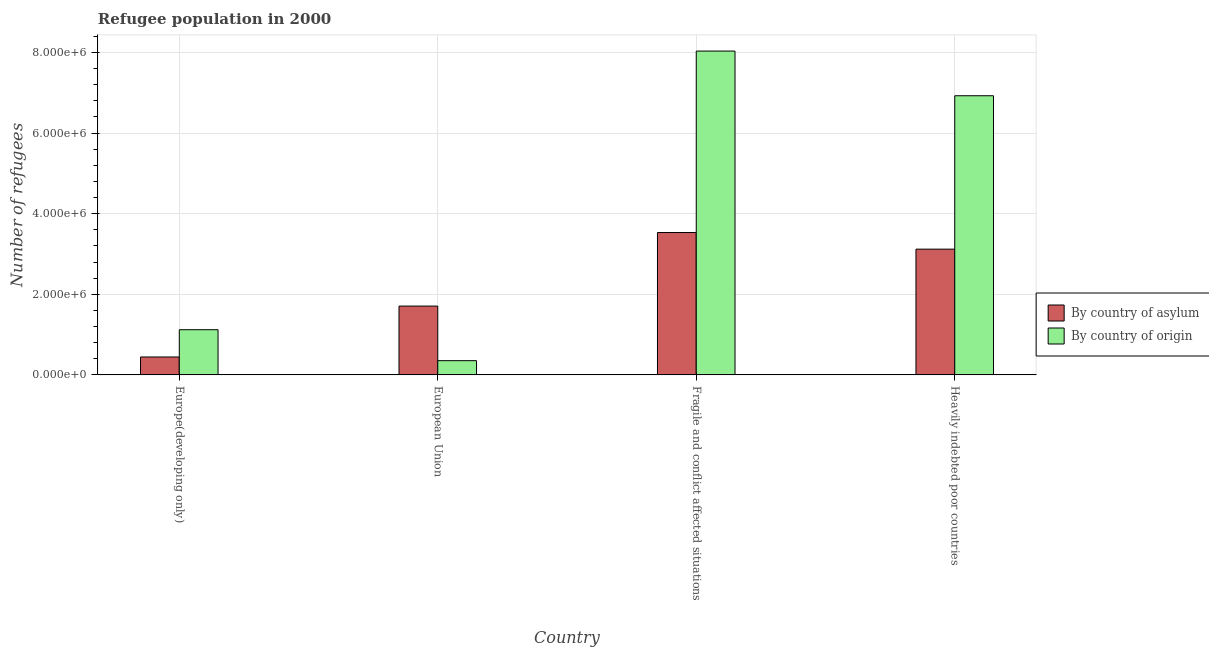Are the number of bars on each tick of the X-axis equal?
Keep it short and to the point. Yes. How many bars are there on the 1st tick from the left?
Your answer should be very brief. 2. What is the label of the 3rd group of bars from the left?
Ensure brevity in your answer.  Fragile and conflict affected situations. In how many cases, is the number of bars for a given country not equal to the number of legend labels?
Your response must be concise. 0. What is the number of refugees by country of asylum in Heavily indebted poor countries?
Your response must be concise. 3.12e+06. Across all countries, what is the maximum number of refugees by country of asylum?
Keep it short and to the point. 3.53e+06. Across all countries, what is the minimum number of refugees by country of origin?
Keep it short and to the point. 3.54e+05. In which country was the number of refugees by country of asylum maximum?
Offer a terse response. Fragile and conflict affected situations. In which country was the number of refugees by country of asylum minimum?
Offer a very short reply. Europe(developing only). What is the total number of refugees by country of origin in the graph?
Provide a short and direct response. 1.64e+07. What is the difference between the number of refugees by country of asylum in Europe(developing only) and that in Fragile and conflict affected situations?
Provide a short and direct response. -3.09e+06. What is the difference between the number of refugees by country of origin in Heavily indebted poor countries and the number of refugees by country of asylum in Europe(developing only)?
Your answer should be compact. 6.48e+06. What is the average number of refugees by country of origin per country?
Offer a very short reply. 4.11e+06. What is the difference between the number of refugees by country of origin and number of refugees by country of asylum in Fragile and conflict affected situations?
Provide a succinct answer. 4.50e+06. What is the ratio of the number of refugees by country of origin in Fragile and conflict affected situations to that in Heavily indebted poor countries?
Give a very brief answer. 1.16. Is the number of refugees by country of asylum in European Union less than that in Fragile and conflict affected situations?
Your answer should be very brief. Yes. What is the difference between the highest and the second highest number of refugees by country of origin?
Ensure brevity in your answer.  1.11e+06. What is the difference between the highest and the lowest number of refugees by country of asylum?
Your answer should be very brief. 3.09e+06. Is the sum of the number of refugees by country of origin in Europe(developing only) and European Union greater than the maximum number of refugees by country of asylum across all countries?
Your response must be concise. No. What does the 1st bar from the left in Fragile and conflict affected situations represents?
Provide a succinct answer. By country of asylum. What does the 1st bar from the right in Europe(developing only) represents?
Give a very brief answer. By country of origin. How many bars are there?
Offer a terse response. 8. Are all the bars in the graph horizontal?
Offer a very short reply. No. What is the difference between two consecutive major ticks on the Y-axis?
Provide a succinct answer. 2.00e+06. Does the graph contain grids?
Offer a terse response. Yes. Where does the legend appear in the graph?
Offer a terse response. Center right. How many legend labels are there?
Provide a short and direct response. 2. How are the legend labels stacked?
Provide a succinct answer. Vertical. What is the title of the graph?
Make the answer very short. Refugee population in 2000. What is the label or title of the X-axis?
Your answer should be very brief. Country. What is the label or title of the Y-axis?
Make the answer very short. Number of refugees. What is the Number of refugees of By country of asylum in Europe(developing only)?
Offer a terse response. 4.45e+05. What is the Number of refugees of By country of origin in Europe(developing only)?
Make the answer very short. 1.12e+06. What is the Number of refugees in By country of asylum in European Union?
Your answer should be compact. 1.71e+06. What is the Number of refugees of By country of origin in European Union?
Your answer should be very brief. 3.54e+05. What is the Number of refugees of By country of asylum in Fragile and conflict affected situations?
Your response must be concise. 3.53e+06. What is the Number of refugees in By country of origin in Fragile and conflict affected situations?
Provide a short and direct response. 8.03e+06. What is the Number of refugees in By country of asylum in Heavily indebted poor countries?
Keep it short and to the point. 3.12e+06. What is the Number of refugees in By country of origin in Heavily indebted poor countries?
Give a very brief answer. 6.93e+06. Across all countries, what is the maximum Number of refugees of By country of asylum?
Ensure brevity in your answer.  3.53e+06. Across all countries, what is the maximum Number of refugees of By country of origin?
Provide a short and direct response. 8.03e+06. Across all countries, what is the minimum Number of refugees in By country of asylum?
Your answer should be very brief. 4.45e+05. Across all countries, what is the minimum Number of refugees of By country of origin?
Ensure brevity in your answer.  3.54e+05. What is the total Number of refugees in By country of asylum in the graph?
Offer a very short reply. 8.80e+06. What is the total Number of refugees of By country of origin in the graph?
Your response must be concise. 1.64e+07. What is the difference between the Number of refugees of By country of asylum in Europe(developing only) and that in European Union?
Offer a very short reply. -1.26e+06. What is the difference between the Number of refugees of By country of origin in Europe(developing only) and that in European Union?
Your answer should be very brief. 7.68e+05. What is the difference between the Number of refugees in By country of asylum in Europe(developing only) and that in Fragile and conflict affected situations?
Offer a terse response. -3.09e+06. What is the difference between the Number of refugees in By country of origin in Europe(developing only) and that in Fragile and conflict affected situations?
Your answer should be compact. -6.91e+06. What is the difference between the Number of refugees in By country of asylum in Europe(developing only) and that in Heavily indebted poor countries?
Offer a very short reply. -2.67e+06. What is the difference between the Number of refugees in By country of origin in Europe(developing only) and that in Heavily indebted poor countries?
Your response must be concise. -5.80e+06. What is the difference between the Number of refugees of By country of asylum in European Union and that in Fragile and conflict affected situations?
Offer a terse response. -1.82e+06. What is the difference between the Number of refugees in By country of origin in European Union and that in Fragile and conflict affected situations?
Your answer should be very brief. -7.68e+06. What is the difference between the Number of refugees in By country of asylum in European Union and that in Heavily indebted poor countries?
Your answer should be very brief. -1.41e+06. What is the difference between the Number of refugees in By country of origin in European Union and that in Heavily indebted poor countries?
Make the answer very short. -6.57e+06. What is the difference between the Number of refugees in By country of asylum in Fragile and conflict affected situations and that in Heavily indebted poor countries?
Provide a short and direct response. 4.12e+05. What is the difference between the Number of refugees of By country of origin in Fragile and conflict affected situations and that in Heavily indebted poor countries?
Your response must be concise. 1.11e+06. What is the difference between the Number of refugees of By country of asylum in Europe(developing only) and the Number of refugees of By country of origin in European Union?
Keep it short and to the point. 9.15e+04. What is the difference between the Number of refugees in By country of asylum in Europe(developing only) and the Number of refugees in By country of origin in Fragile and conflict affected situations?
Keep it short and to the point. -7.59e+06. What is the difference between the Number of refugees in By country of asylum in Europe(developing only) and the Number of refugees in By country of origin in Heavily indebted poor countries?
Provide a short and direct response. -6.48e+06. What is the difference between the Number of refugees of By country of asylum in European Union and the Number of refugees of By country of origin in Fragile and conflict affected situations?
Ensure brevity in your answer.  -6.33e+06. What is the difference between the Number of refugees of By country of asylum in European Union and the Number of refugees of By country of origin in Heavily indebted poor countries?
Provide a short and direct response. -5.22e+06. What is the difference between the Number of refugees of By country of asylum in Fragile and conflict affected situations and the Number of refugees of By country of origin in Heavily indebted poor countries?
Make the answer very short. -3.39e+06. What is the average Number of refugees of By country of asylum per country?
Your response must be concise. 2.20e+06. What is the average Number of refugees in By country of origin per country?
Make the answer very short. 4.11e+06. What is the difference between the Number of refugees in By country of asylum and Number of refugees in By country of origin in Europe(developing only)?
Your answer should be compact. -6.76e+05. What is the difference between the Number of refugees in By country of asylum and Number of refugees in By country of origin in European Union?
Offer a very short reply. 1.35e+06. What is the difference between the Number of refugees of By country of asylum and Number of refugees of By country of origin in Fragile and conflict affected situations?
Make the answer very short. -4.50e+06. What is the difference between the Number of refugees in By country of asylum and Number of refugees in By country of origin in Heavily indebted poor countries?
Your answer should be very brief. -3.81e+06. What is the ratio of the Number of refugees in By country of asylum in Europe(developing only) to that in European Union?
Offer a terse response. 0.26. What is the ratio of the Number of refugees of By country of origin in Europe(developing only) to that in European Union?
Ensure brevity in your answer.  3.17. What is the ratio of the Number of refugees of By country of asylum in Europe(developing only) to that in Fragile and conflict affected situations?
Give a very brief answer. 0.13. What is the ratio of the Number of refugees of By country of origin in Europe(developing only) to that in Fragile and conflict affected situations?
Give a very brief answer. 0.14. What is the ratio of the Number of refugees of By country of asylum in Europe(developing only) to that in Heavily indebted poor countries?
Your response must be concise. 0.14. What is the ratio of the Number of refugees of By country of origin in Europe(developing only) to that in Heavily indebted poor countries?
Offer a terse response. 0.16. What is the ratio of the Number of refugees of By country of asylum in European Union to that in Fragile and conflict affected situations?
Your answer should be compact. 0.48. What is the ratio of the Number of refugees in By country of origin in European Union to that in Fragile and conflict affected situations?
Offer a very short reply. 0.04. What is the ratio of the Number of refugees of By country of asylum in European Union to that in Heavily indebted poor countries?
Offer a terse response. 0.55. What is the ratio of the Number of refugees in By country of origin in European Union to that in Heavily indebted poor countries?
Offer a very short reply. 0.05. What is the ratio of the Number of refugees in By country of asylum in Fragile and conflict affected situations to that in Heavily indebted poor countries?
Your answer should be very brief. 1.13. What is the ratio of the Number of refugees in By country of origin in Fragile and conflict affected situations to that in Heavily indebted poor countries?
Give a very brief answer. 1.16. What is the difference between the highest and the second highest Number of refugees in By country of asylum?
Make the answer very short. 4.12e+05. What is the difference between the highest and the second highest Number of refugees in By country of origin?
Keep it short and to the point. 1.11e+06. What is the difference between the highest and the lowest Number of refugees in By country of asylum?
Give a very brief answer. 3.09e+06. What is the difference between the highest and the lowest Number of refugees in By country of origin?
Your answer should be very brief. 7.68e+06. 